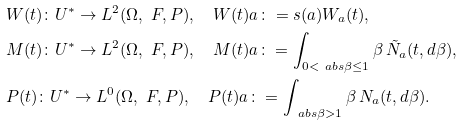Convert formula to latex. <formula><loc_0><loc_0><loc_500><loc_500>& W ( t ) \colon U ^ { \ast } \to L ^ { 2 } ( \Omega , \ F , P ) , \quad W ( t ) a \colon = s ( a ) W _ { a } ( t ) , \\ & M ( t ) \colon U ^ { \ast } \to L ^ { 2 } ( \Omega , \ F , P ) , \quad M ( t ) a \colon = \int _ { 0 < \ a b s { \beta } \leq 1 } \beta \, \tilde { N } _ { a } ( t , d \beta ) , \\ & P ( t ) \colon U ^ { \ast } \to L ^ { 0 } ( \Omega , \ F , P ) , \quad P ( t ) a \colon = \int _ { \ a b s { \beta } > 1 } \beta \, N _ { a } ( t , d \beta ) .</formula> 